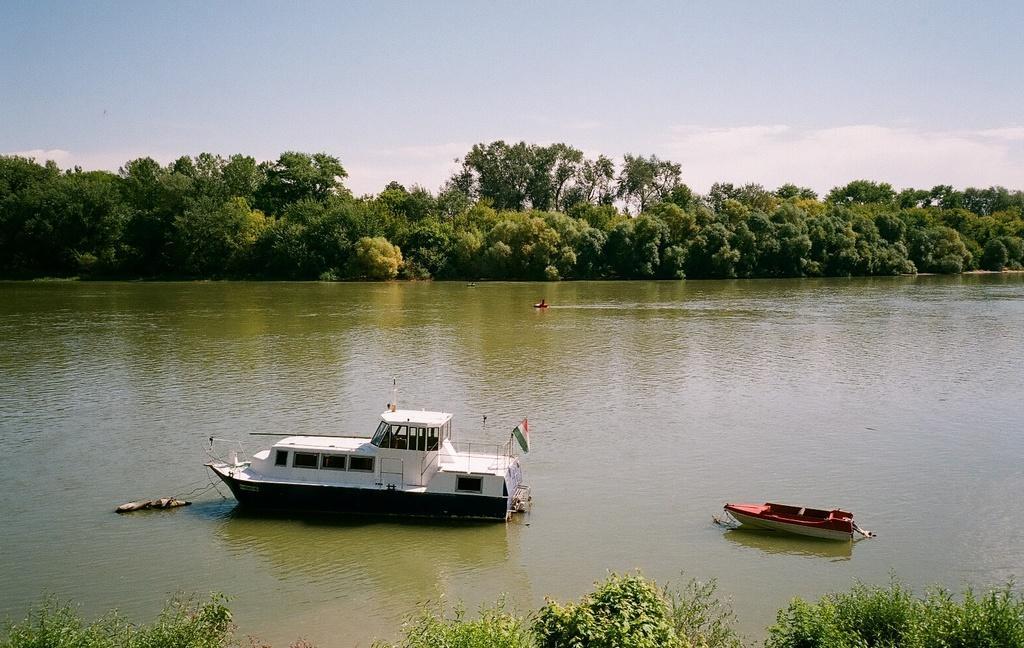Could you give a brief overview of what you see in this image? At the bottom of this image, there are plants and there are two boats on the water. In the background, there is a boat on the water, there are trees and there are clouds in the blue sky. 